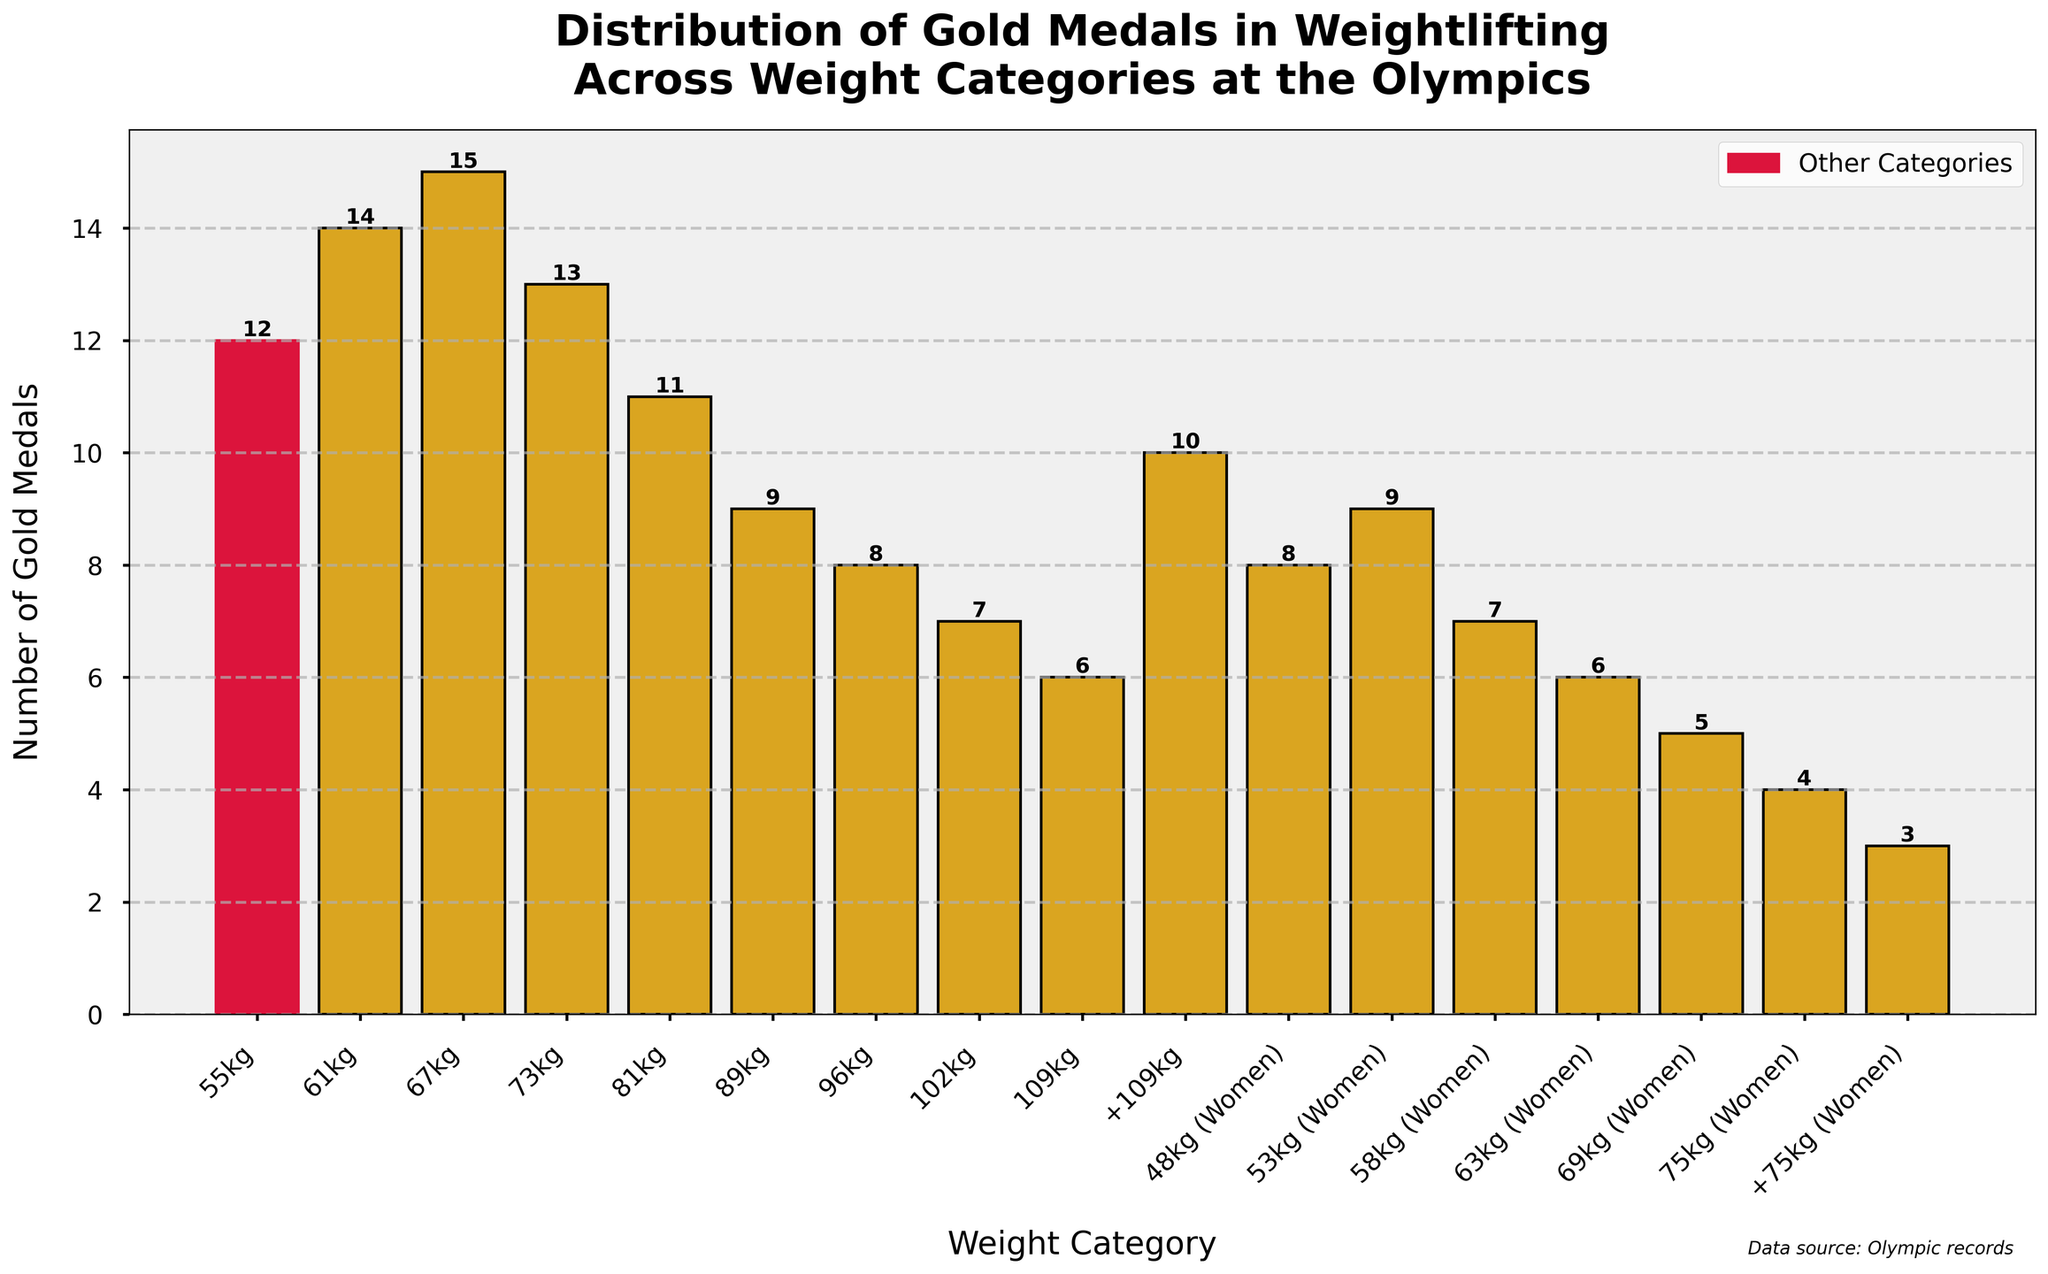Which weight category won the most gold medals? By examining the heights of the bars, the weight category with the tallest bar represents the most gold medals won. The "67kg" category has the tallest bar with 15 gold medals.
Answer: 67kg Which weight category has the fewest gold medals among the women? By looking at the heights of the bars for the female categories (those with "Women"), we see that "+75kg (Women)" has the shortest bar with 3 gold medals.
Answer: +75kg (Women) How many more gold medals does the 61kg category have compared to the 109kg category? The 61kg category has 14 gold medals and the 109kg category has 6 gold medals. The difference is 14 - 6.
Answer: 8 Sum up the total number of gold medals won by all male categories. Add the counts of gold medals for all male categories: 55kg (12) + 61kg (14) + 67kg (15) + 73kg (13) + 81kg (11) + 89kg (9) + 96kg (8) + 102kg (7) + 109kg (6) + +109kg (10) = 105.
Answer: 105 Which gender category (men's or women's) has won more gold medals in total? Sum the gold medals for all male and female categories. Males: 105. Females: 48kg (Women) 8 + 53kg (Women) 9 + 58kg (Women) 7 + 63kg (Women) 6 + 69kg (Women) 5 + 75kg (Women) 4 + +75kg (Women) 3 = 42. Males have won more gold medals.
Answer: Men What is the average number of gold medals won by weight categories weighing above 75kg (including +75kg) for women? The categories above 75kg for women with their gold medal counts are 75kg (Women) 4 and +75kg (Women) 3. Average = (4 + 3) / 2 = 3.5.
Answer: 3.5 Which category has more gold medals, 55kg or 81kg? By comparing the heights of the bars, we see that the 55kg category has 12 gold medals while the 81kg category has 11 gold medals. Thus, the 55kg category has more gold medals.
Answer: 55kg How many categories have won fewer than 10 gold medals? Count the bars representing fewer than 10 medals: 89kg, 96kg, 102kg, 109kg, 48kg (Women), 58kg (Women), 63kg (Women), 69kg (Women), 75kg (Women), and +75kg (Women). There are 10 such categories.
Answer: 10 Describe the prominence of your weight category (55kg) visually. The bar representing the 55kg category is colored crimson, which stands out compared to other bars colored goldenrod. This coloring emphasizes its significance.
Answer: Crimson-colored, quite tall 